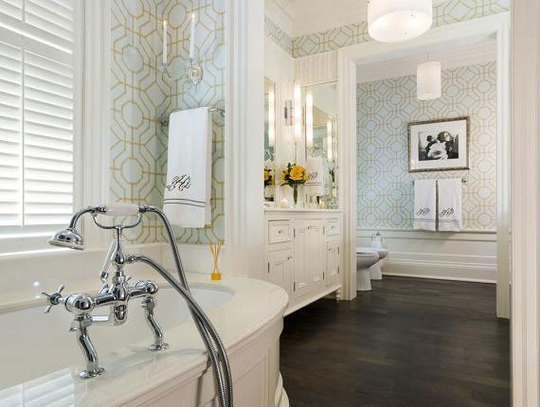Describe the objects in this image and their specific colors. I can see toilet in lightgray, darkgray, and gray tones, toilet in lightgray, darkgray, and gray tones, and vase in lightgray, beige, darkgreen, tan, and black tones in this image. 